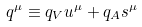<formula> <loc_0><loc_0><loc_500><loc_500>q ^ { \mu } \equiv q _ { V } u ^ { \mu } + q _ { A } s ^ { \mu }</formula> 